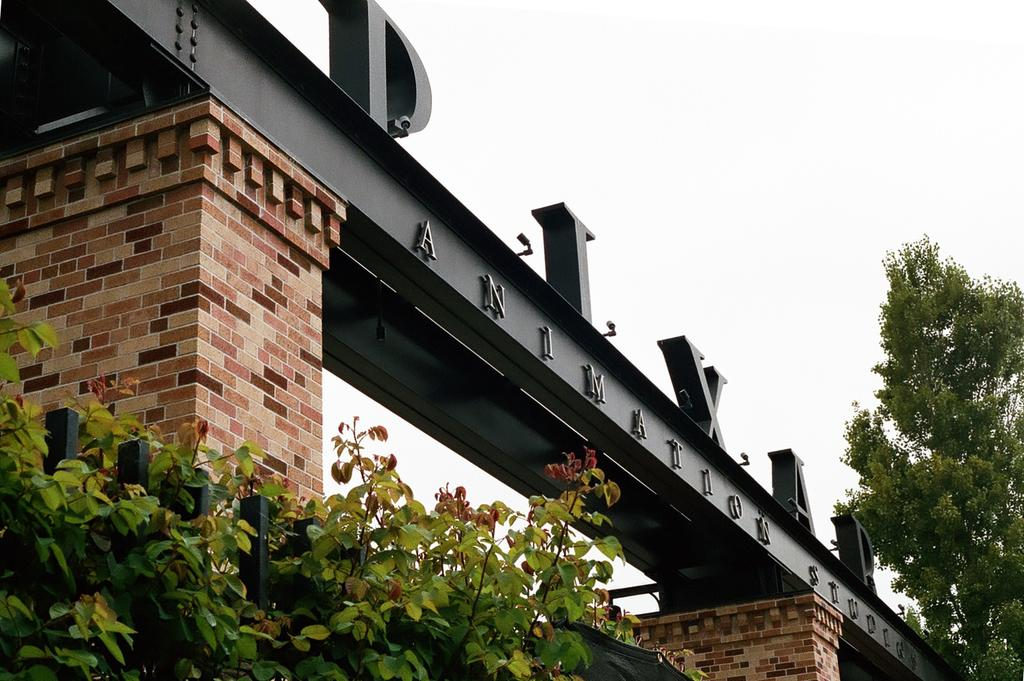What type of vegetation is on the left side of the image? There are trees on the left side of the image. What can be seen in the image besides the trees? There is a construction in the image. What is written on the construction? The construction has a name on it. How would you describe the weather in the image? The sky is cloudy in the image. Who is the owner of the beds in the image? There are no beds present in the image. What type of team is working on the construction in the image? There is no team visible in the image; only the construction and trees are present. 